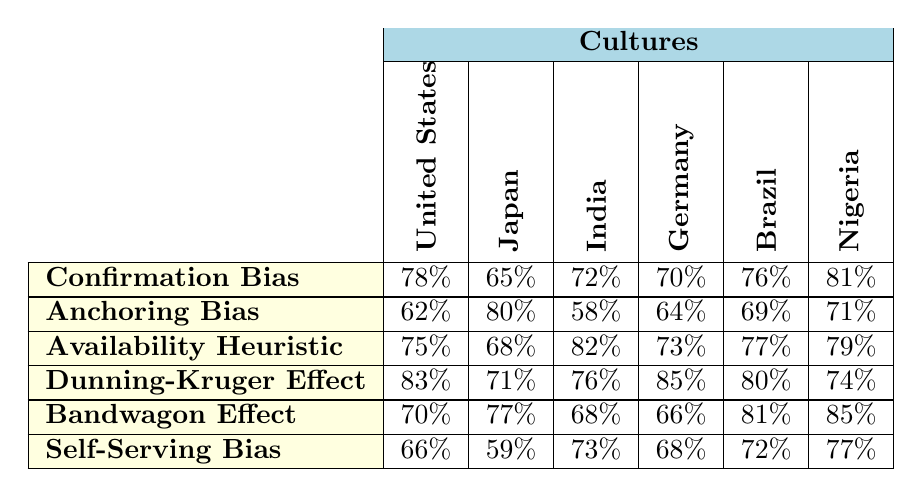What is the prevalence rate of Confirmation Bias in Nigeria? From the table, the prevalence rate for Confirmation Bias in Nigeria is found in the corresponding cell for Nigeria under the Confirmation Bias row, which shows 81%.
Answer: 81% Which culture has the highest prevalence of the Dunning-Kruger Effect? Looking at the Dunning-Kruger Effect row, the highest prevalence rate is 85%, which is under the Germany column.
Answer: Germany What is the average prevalence rate of the Bandwagon Effect across all cultures? To find the average, sum the prevalence rates for the Bandwagon Effect (70 + 77 + 68 + 66 + 81 + 85 = 447) and divide by the number of cultures (6). So, the average is 447/6 = 74.5.
Answer: 74.5 In which culture is the Availability Heuristic the least prevalent? The Availability Heuristic row shows the rates: 75% (U.S.), 68% (Japan), 82% (India), 73% (Germany), 77% (Brazil), and 79% (Nigeria). The lowest value is 68%, which corresponds to Japan.
Answer: Japan Is self-serving bias more prevalent in the United States than in Japan? Comparing the Self-Serving Bias prevalence: 66% (U.S.) and 59% (Japan). Since 66% is greater than 59%, the answer is yes.
Answer: Yes What is the difference in prevalence rates of Anchoring Bias between the United States and Germany? The Anchoring Bias rate for the U.S. is 62% and for Germany is 64%. The difference is calculated as 64% - 62% = 2%.
Answer: 2% Which cognitive bias shows the highest overall prevalence across all cultures? Examining the highest values per bias: Confirmation Bias (81%), Anchoring Bias (80%), Availability Heuristic (82%), Dunning-Kruger Effect (85%), Bandwagon Effect (85%), Self-Serving Bias (77%). The maximum is 85% for Dunning-Kruger Effect and Bandwagon Effect.
Answer: Dunning-Kruger Effect and Bandwagon Effect Which culture has the lowest prevalence rate of Self-Serving Bias? By reviewing the Self-Serving Bias row, we see the values: 66% (U.S.), 59% (Japan), 73% (India), 68% (Germany), 72% (Brazil), and 77% (Nigeria). The lowest is 59%, indicating Japan has the lowest rate.
Answer: Japan What is the median prevalence rate of the Availability Heuristic across these cultures? The prevalence rates for Availability Heuristic are: 75%, 68%, 82%, 73%, 77%, and 79%. Arranging them gives: 68%, 73%, 75%, 77%, 79%, 82%. Since there are 6 values, the median is the average of the 3rd and 4th values: (75 + 77)/2 = 76%.
Answer: 76% Did any researcher study Confirmation Bias in both the United States and Germany? Checking the corresponding researchers: Dr. Emily Chen (U.S.) and Dr. Anna Müller (Germany) both studied Confirmation Bias, which confirms that there was a study for both cultures in this category.
Answer: Yes 